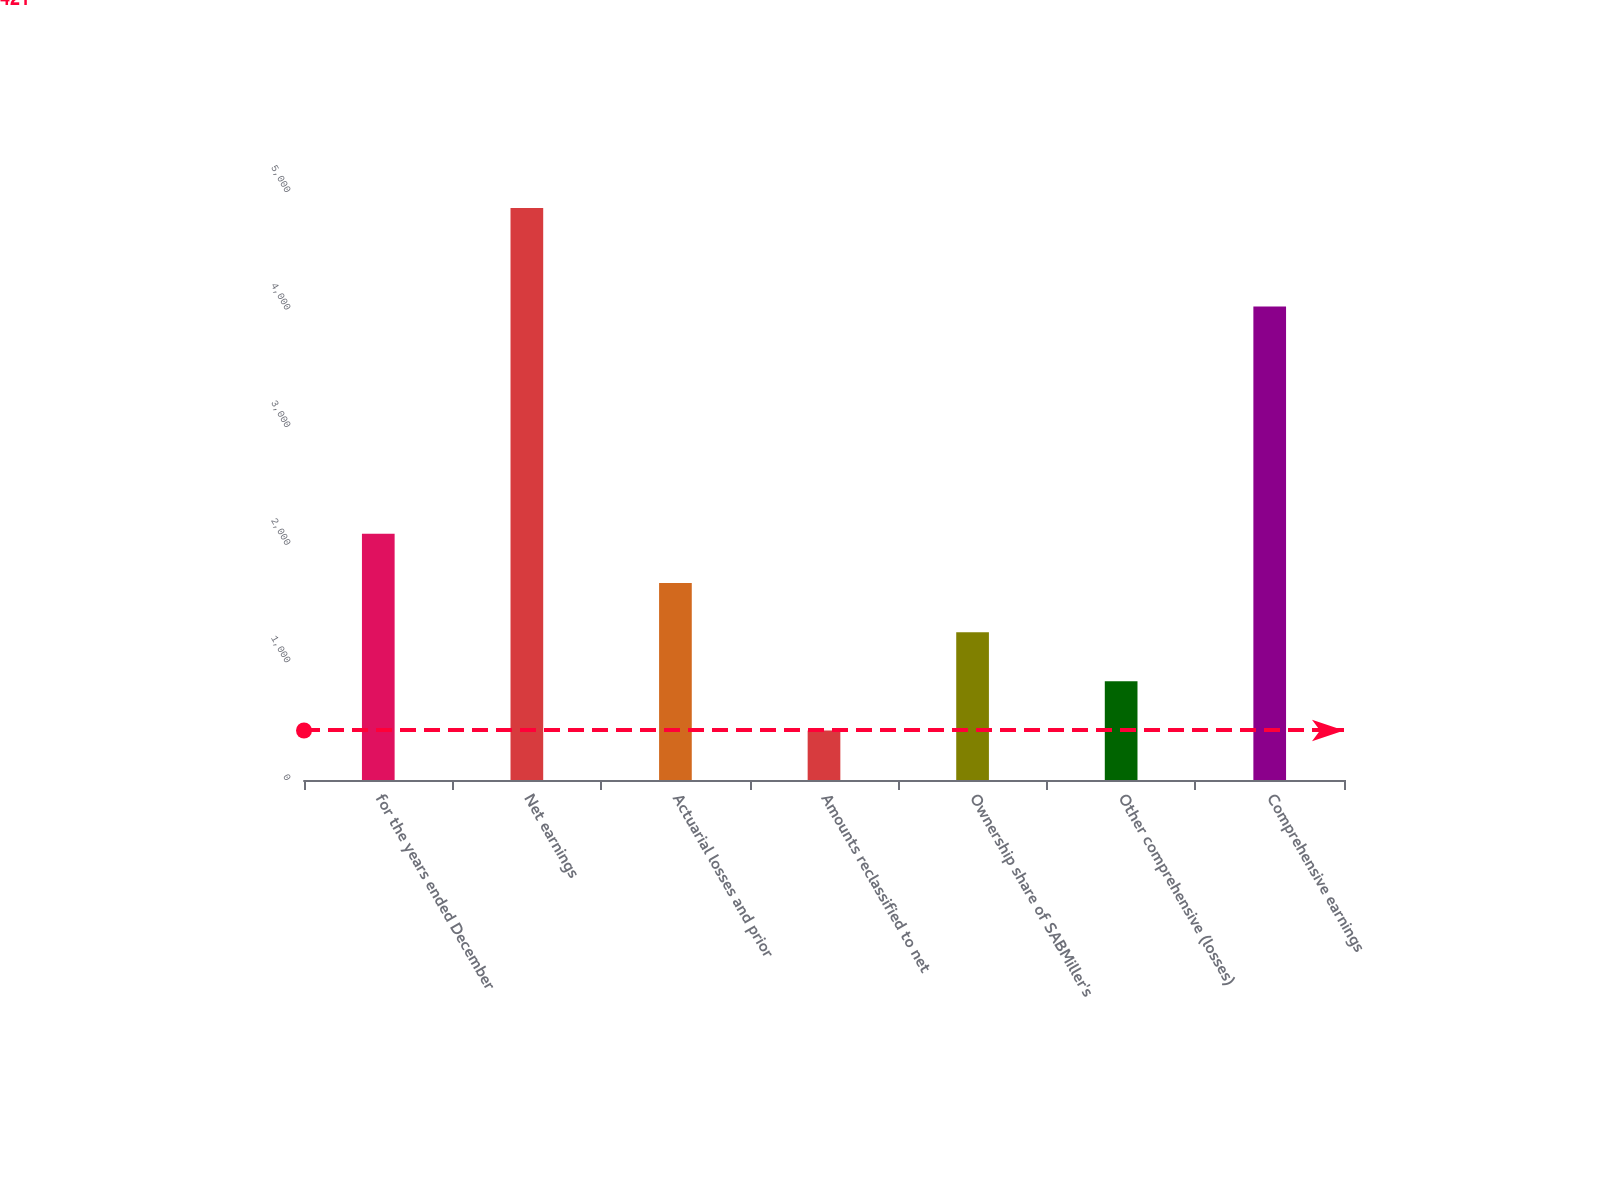Convert chart to OTSL. <chart><loc_0><loc_0><loc_500><loc_500><bar_chart><fcel>for the years ended December<fcel>Net earnings<fcel>Actuarial losses and prior<fcel>Amounts reclassified to net<fcel>Ownership share of SABMiller's<fcel>Other comprehensive (losses)<fcel>Comprehensive earnings<nl><fcel>2093<fcel>4863<fcel>1675<fcel>421<fcel>1257<fcel>839<fcel>4027<nl></chart> 